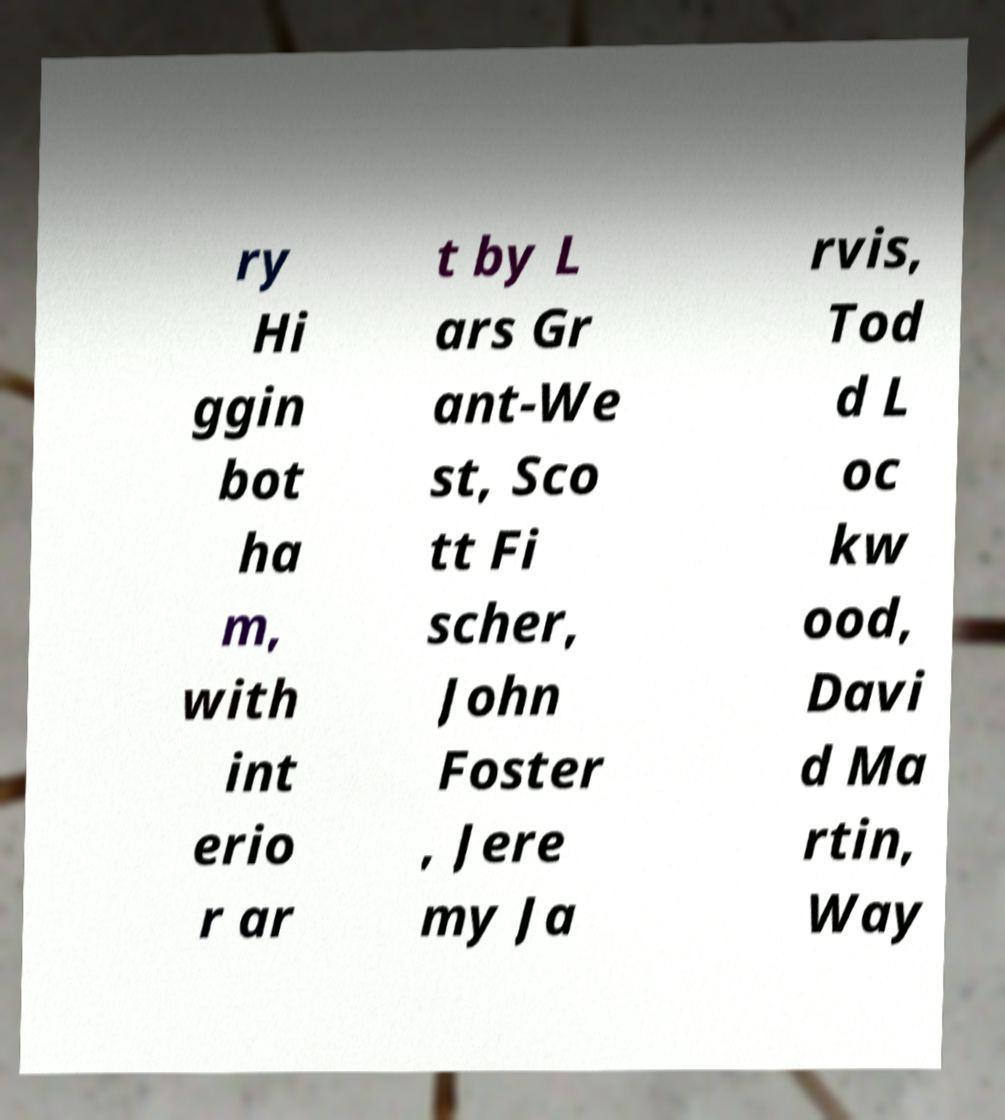I need the written content from this picture converted into text. Can you do that? ry Hi ggin bot ha m, with int erio r ar t by L ars Gr ant-We st, Sco tt Fi scher, John Foster , Jere my Ja rvis, Tod d L oc kw ood, Davi d Ma rtin, Way 